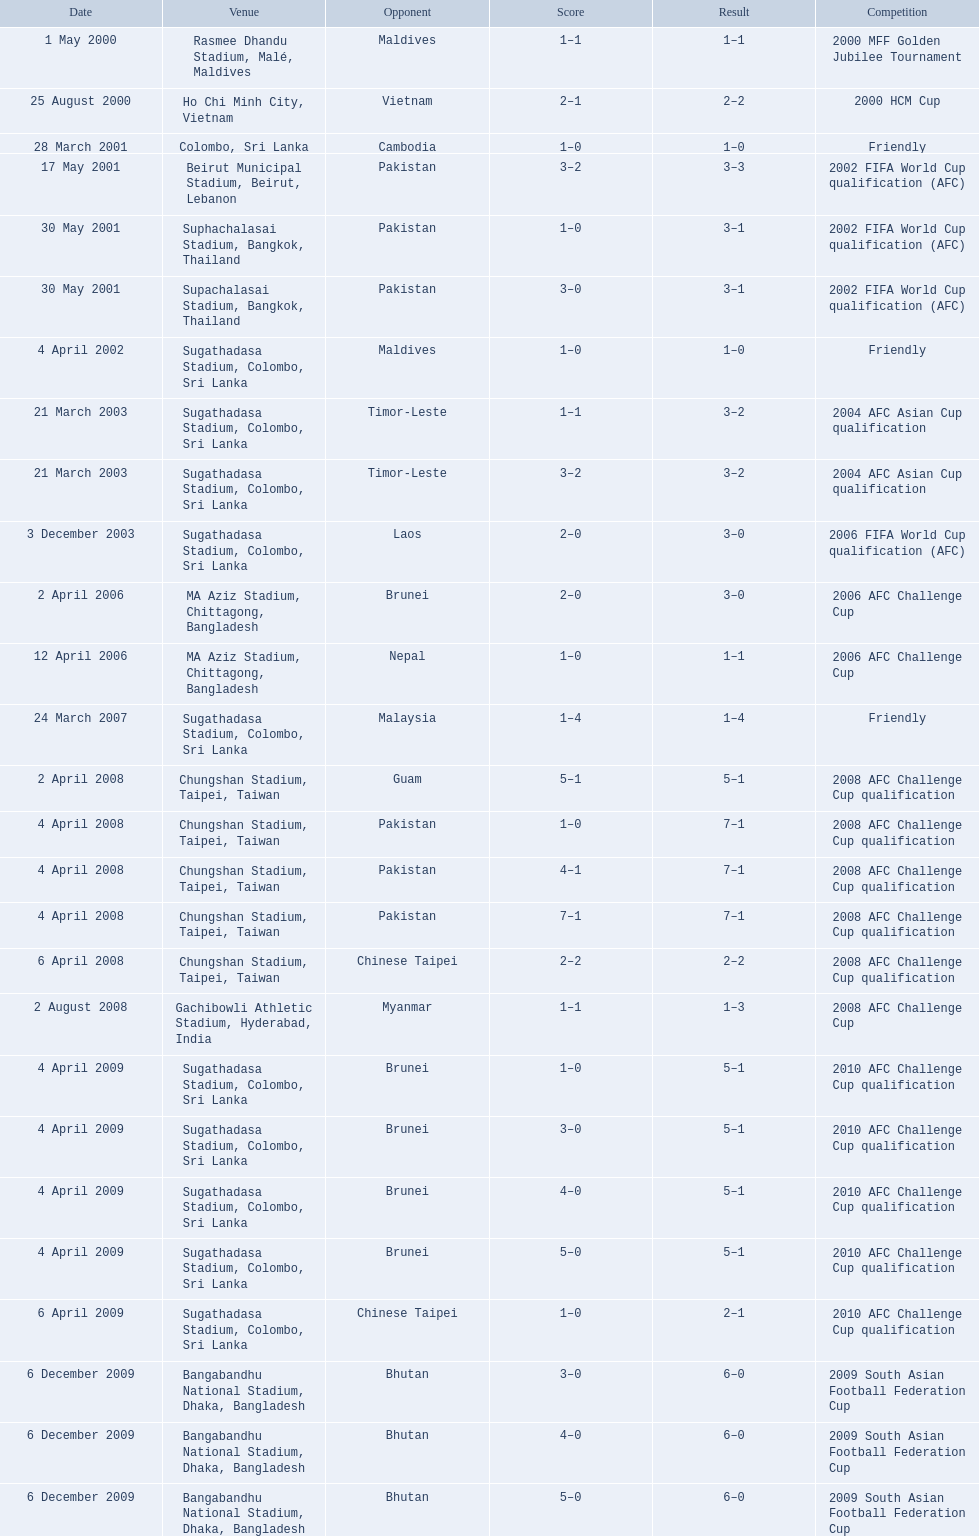What venues are listed? Rasmee Dhandu Stadium, Malé, Maldives, Ho Chi Minh City, Vietnam, Colombo, Sri Lanka, Beirut Municipal Stadium, Beirut, Lebanon, Suphachalasai Stadium, Bangkok, Thailand, MA Aziz Stadium, Chittagong, Bangladesh, Sugathadasa Stadium, Colombo, Sri Lanka, Chungshan Stadium, Taipei, Taiwan, Gachibowli Athletic Stadium, Hyderabad, India, Sugathadasa Stadium, Colombo, Sri Lanka, Bangabandhu National Stadium, Dhaka, Bangladesh. Which is top listed? Rasmee Dhandu Stadium, Malé, Maldives. 